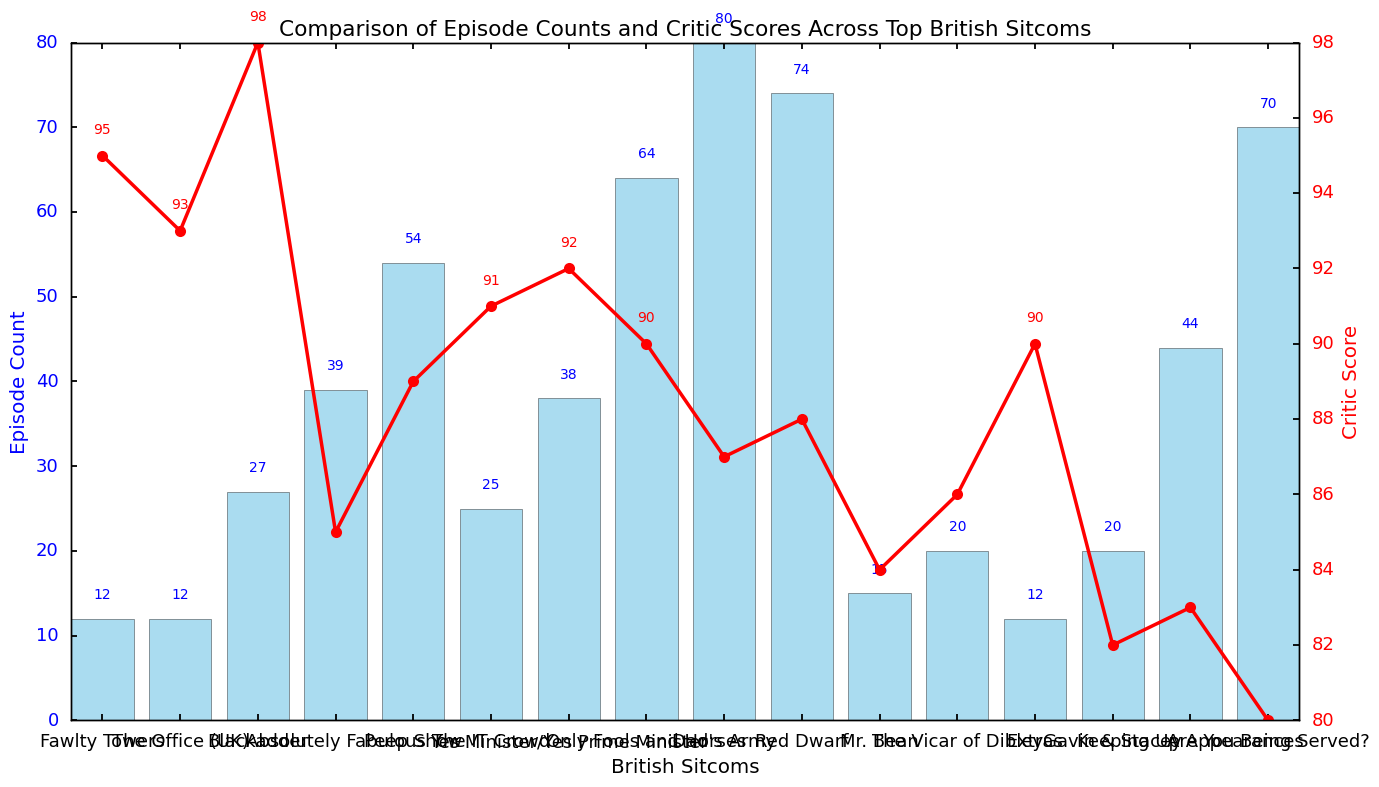Which sitcom has the highest episode count? The bar representing the sitcom with the highest episode count is the tallest. This is "Dad's Army" with 80 episodes.
Answer: Dad's Army How many sitcoms have episode counts equal to 12? There are bars of the same height corresponding to sitcoms with episode counts equal to 12, which are "Fawlty Towers," "The Office (UK)," and "Extras." Count these bars.
Answer: 3 What is the difference between the episode count of "Only Fools and Horses" and "The IT Crowd"? Find the height of the bars corresponding to "Only Fools and Horses" and "The IT Crowd" which are 64 and 25 respectively. Then subtract 25 from 64.
Answer: 39 Which sitcom has the highest critic score? The line plot shows critic scores using red dots. The highest point on the line marks the highest critic score, which is for "Blackadder" with a score of 98.
Answer: Blackadder What is the average episode count of sitcoms with a critic score of 90 or more? Identify the sitcoms with critic scores of 90 or more. Sum their episode counts and then divide by the number of these sitcoms. (Sitcoms: "Fawlty Towers," "The Office (UK)," "Blackadder," "The IT Crowd," "Only Fools and Horses," "Yes Minister/Yes Prime Minister," "Extras") Sum of episode counts is 12 + 12 + 27 + 25 + 64 + 38 + 12 = 190. There are 7 sitcoms. 190 / 7 ≈ 27.14
Answer: 27.14 Which two sitcoms have the same episode count of 12? From the episode count bars with annotations, identify all with the mark 12, then name two of them. Examples include "Fawlty Towers" and "The Office (UK)."
Answer: Fawlty Towers and The Office (UK) What is the critic score of "The Vicar of Dibley"? Locate the point on the red line corresponding to "The Vicar of Dibley" and read the vertical axis for the critic score, shown by the annotation.
Answer: 86 Which sitcom has both a critic score of 90 and the same episode count as "Extras"? "Extras" has 12 episodes and a critic score of 90. Identify other sitcoms with a critic score of 90 by looking at the red line and annotations. "Only Fools and Horses" meets the score criterion but not the episode count; therefore, no other sitcom meets both criteria.
Answer: None Is "Mr. Bean" critic score below or above average? Calculate the average critic score of all the sitcoms, then compare "Mr. Bean" score with this average. Average critic score = (95+93+98+85+89+91+92+90+87+88+84+86+90+82+83+80)/16 = 1643/16 ≈ 102.69. "Mr. Bean" score = 84, which is below the average.
Answer: Below 